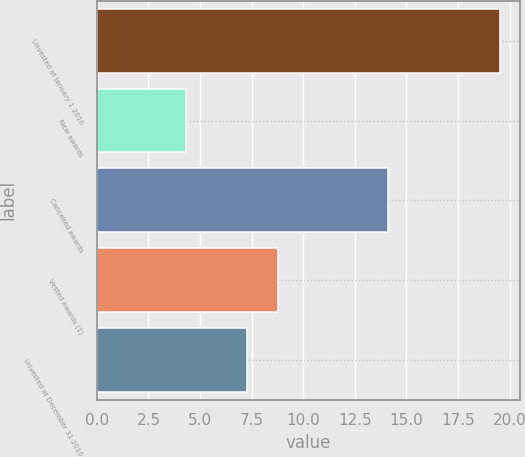<chart> <loc_0><loc_0><loc_500><loc_500><bar_chart><fcel>Unvested at January 1 2010<fcel>New awards<fcel>Cancelled awards<fcel>Vested awards (1)<fcel>Unvested at December 31 2010<nl><fcel>19.53<fcel>4.34<fcel>14.1<fcel>8.8<fcel>7.28<nl></chart> 